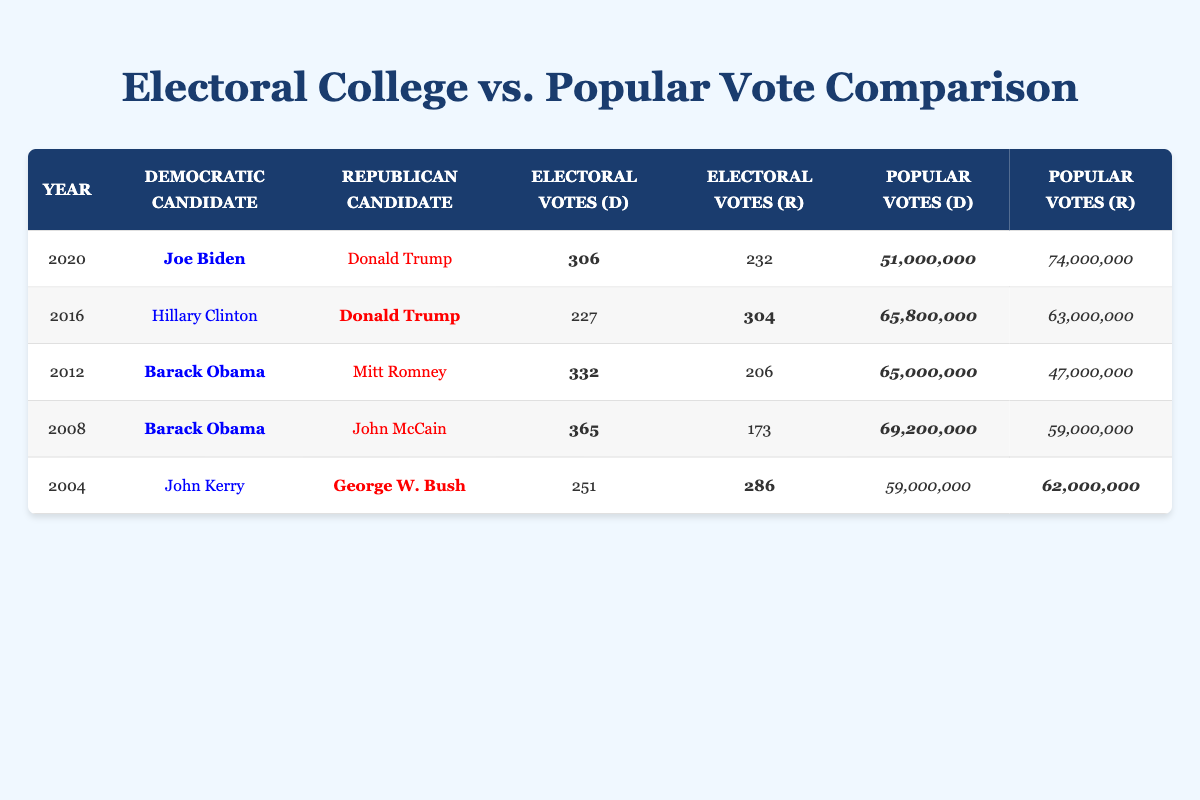What was the popular vote for Joe Biden in 2020? The table shows that Joe Biden received 51,000,000 popular votes in 2020.
Answer: 51,000,000 Which candidate had more electoral votes in the 2016 election? Donald Trump had 304 electoral votes while Hillary Clinton had 227, so Trump had more electoral votes in 2016.
Answer: Donald Trump Did Barack Obama win the popular vote in both 2008 and 2012? In 2008, Barack Obama received 69,200,000 popular votes, and in 2012, he received 65,000,000 votes. Both years show he was the winner in popular votes.
Answer: Yes What is the difference in electoral votes between the winning candidate and the losing candidate in the 2012 election? Barack Obama received 332 electoral votes and Mitt Romney received 206 electoral votes. The difference is calculated as 332 - 206 = 126.
Answer: 126 In which election did the losing candidate receive the most popular votes? In 2020, the losing candidate, Donald Trump, received 74,000,000 popular votes, which is more than any losing candidates in previous elections.
Answer: 2020 What total number of popular votes did the Democratic candidates receive in the 2004 election? John Kerry received 59,000,000 popular votes as the Democratic candidate in 2004, and since he was the only Democratic candidate listed, it totals to 59,000,000.
Answer: 59,000,000 Was the winning candidate in the 2020 election the same candidate who received more popular votes? In 2020, Joe Biden was the winning candidate with 51,000,000 votes, while Donald Trump received 74,000,000. Thus, the winning candidate did not receive the most popular votes.
Answer: No What was the total number of electoral votes in the 2008 election? Barack Obama received 365 electoral votes and John McCain received 173. The total is calculated as 365 + 173 = 538 electoral votes.
Answer: 538 In which year did the Democratic candidate have the least electoral votes won? In 2016, Hillary Clinton had 227 electoral votes, which is less than any Democratic candidate in other listed years.
Answer: 2016 